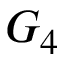<formula> <loc_0><loc_0><loc_500><loc_500>G _ { 4 }</formula> 